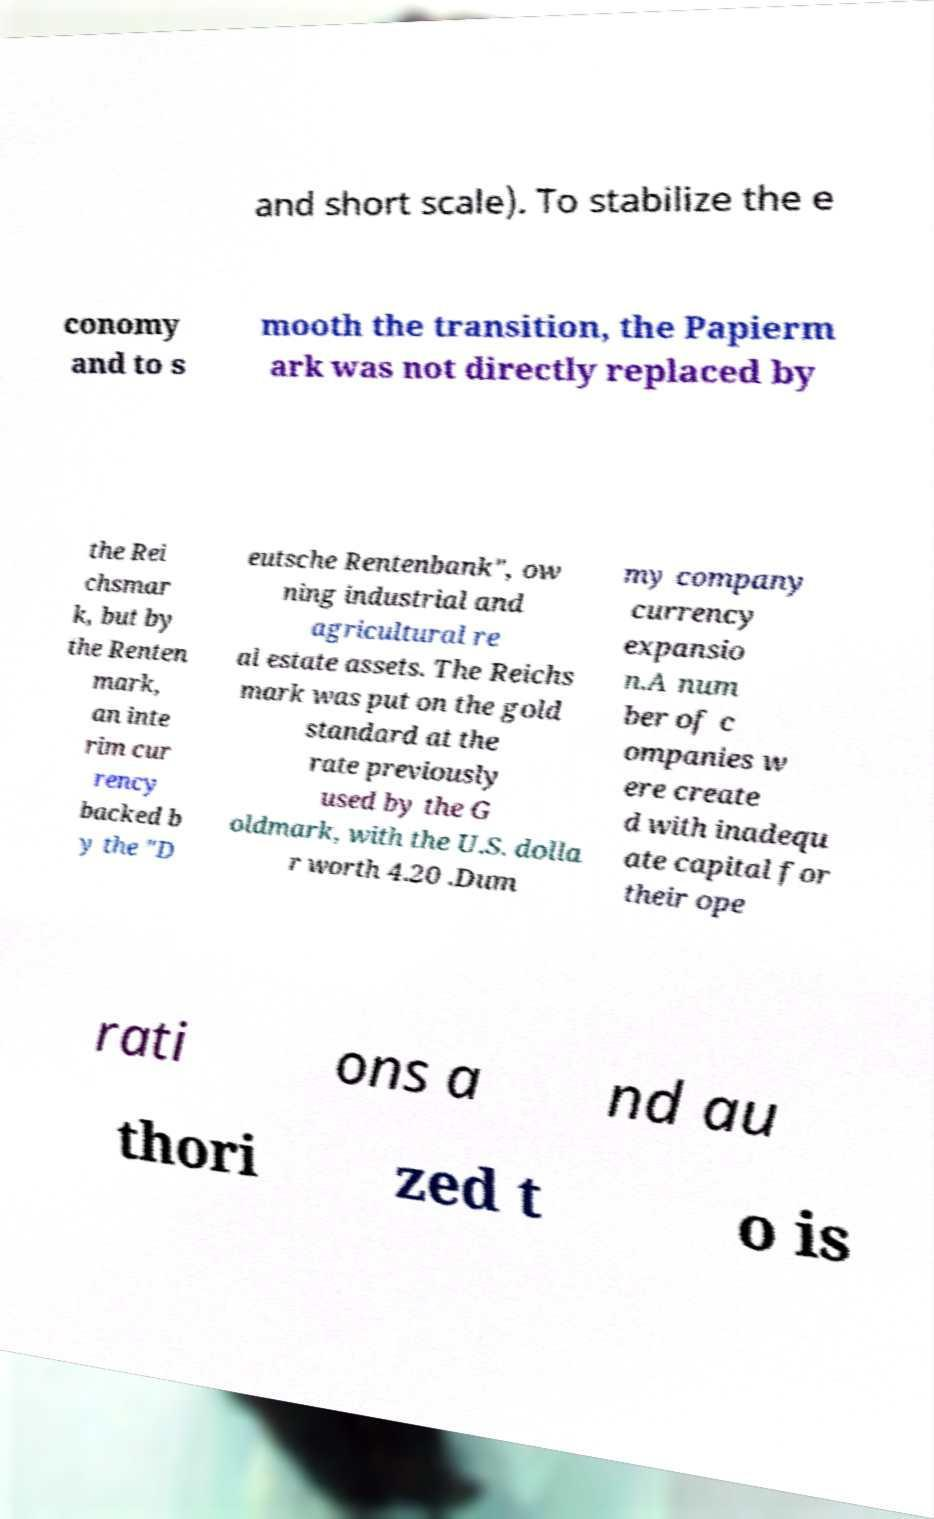What messages or text are displayed in this image? I need them in a readable, typed format. and short scale). To stabilize the e conomy and to s mooth the transition, the Papierm ark was not directly replaced by the Rei chsmar k, but by the Renten mark, an inte rim cur rency backed b y the "D eutsche Rentenbank", ow ning industrial and agricultural re al estate assets. The Reichs mark was put on the gold standard at the rate previously used by the G oldmark, with the U.S. dolla r worth 4.20 .Dum my company currency expansio n.A num ber of c ompanies w ere create d with inadequ ate capital for their ope rati ons a nd au thori zed t o is 